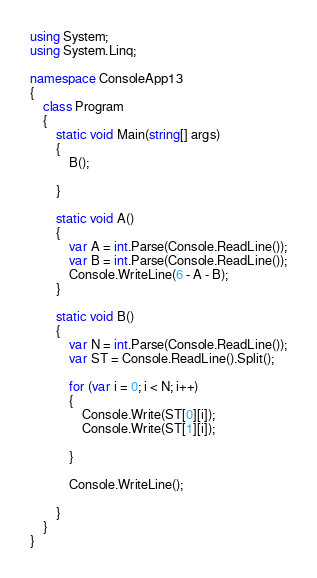<code> <loc_0><loc_0><loc_500><loc_500><_C#_>using System;
using System.Linq;

namespace ConsoleApp13
{
    class Program
    {
        static void Main(string[] args)
        {
            B();

        }

        static void A()
        {
            var A = int.Parse(Console.ReadLine());
            var B = int.Parse(Console.ReadLine());
            Console.WriteLine(6 - A - B);
        }

        static void B()
        {
            var N = int.Parse(Console.ReadLine());
            var ST = Console.ReadLine().Split();

            for (var i = 0; i < N; i++)
            {
                Console.Write(ST[0][i]);
                Console.Write(ST[1][i]);

            }

            Console.WriteLine();

        }
    }
}
</code> 